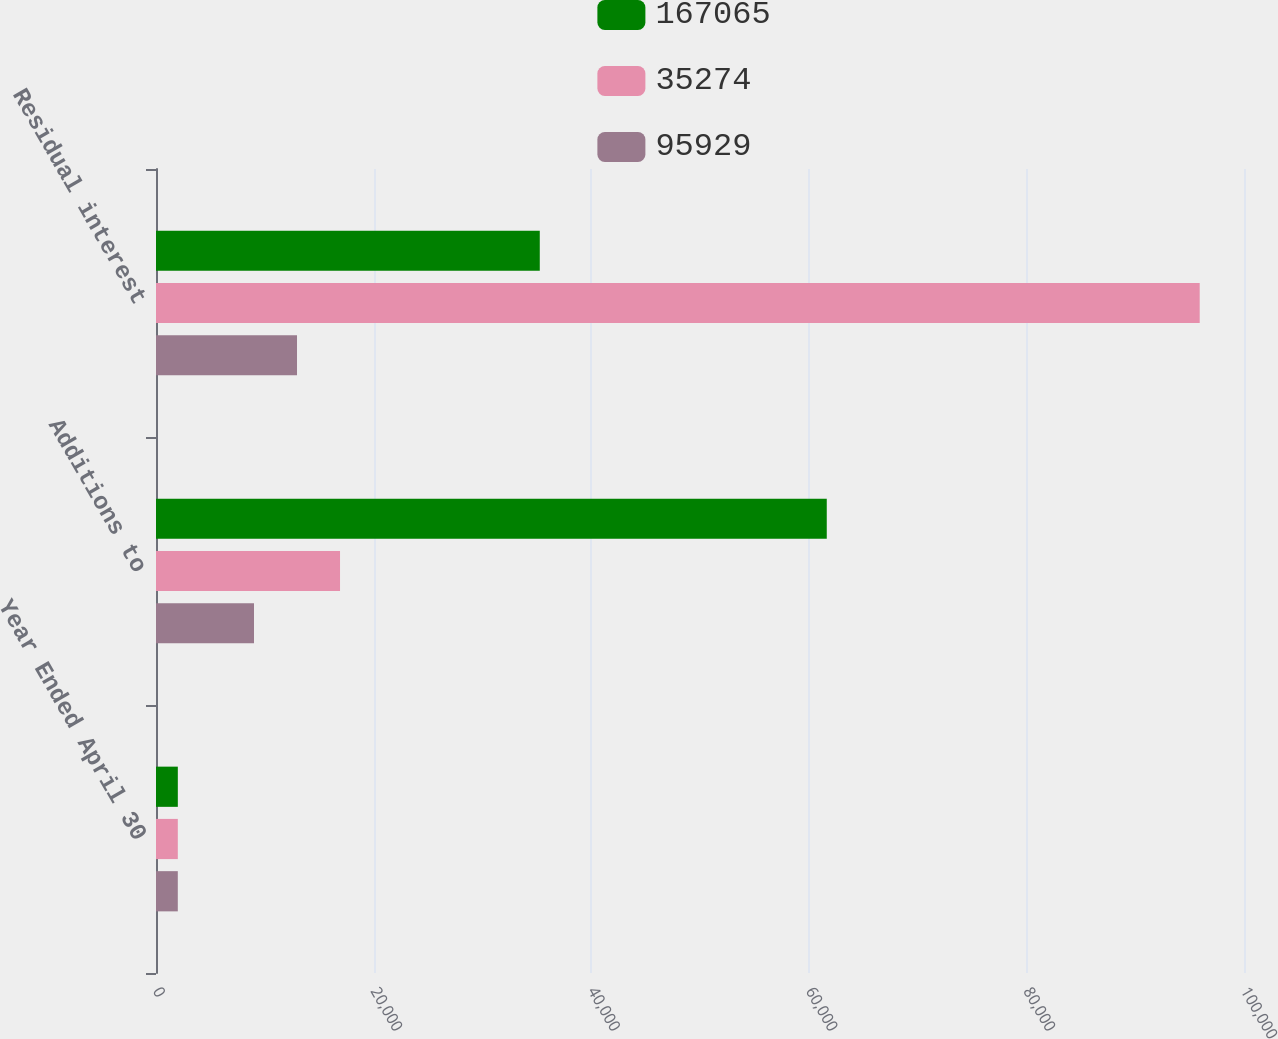Convert chart to OTSL. <chart><loc_0><loc_0><loc_500><loc_500><stacked_bar_chart><ecel><fcel>Year Ended April 30<fcel>Additions to<fcel>Residual interest<nl><fcel>167065<fcel>2006<fcel>61651<fcel>35274<nl><fcel>35274<fcel>2005<fcel>16914<fcel>95929<nl><fcel>95929<fcel>2004<fcel>9007<fcel>12960.5<nl></chart> 